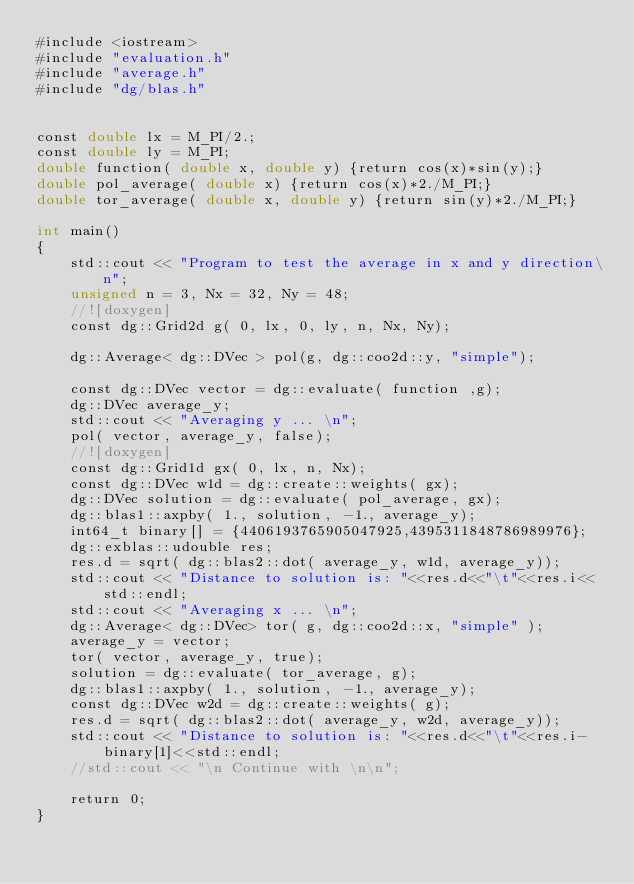<code> <loc_0><loc_0><loc_500><loc_500><_Cuda_>#include <iostream>
#include "evaluation.h"
#include "average.h"
#include "dg/blas.h"


const double lx = M_PI/2.;
const double ly = M_PI;
double function( double x, double y) {return cos(x)*sin(y);}
double pol_average( double x) {return cos(x)*2./M_PI;}
double tor_average( double x, double y) {return sin(y)*2./M_PI;}

int main()
{
    std::cout << "Program to test the average in x and y direction\n";
    unsigned n = 3, Nx = 32, Ny = 48;
    //![doxygen]
    const dg::Grid2d g( 0, lx, 0, ly, n, Nx, Ny);

    dg::Average< dg::DVec > pol(g, dg::coo2d::y, "simple");

    const dg::DVec vector = dg::evaluate( function ,g);
    dg::DVec average_y;
    std::cout << "Averaging y ... \n";
    pol( vector, average_y, false);
    //![doxygen]
    const dg::Grid1d gx( 0, lx, n, Nx);
    const dg::DVec w1d = dg::create::weights( gx);
    dg::DVec solution = dg::evaluate( pol_average, gx);
    dg::blas1::axpby( 1., solution, -1., average_y);
    int64_t binary[] = {4406193765905047925,4395311848786989976};
    dg::exblas::udouble res;
    res.d = sqrt( dg::blas2::dot( average_y, w1d, average_y));
    std::cout << "Distance to solution is: "<<res.d<<"\t"<<res.i<<std::endl;
    std::cout << "Averaging x ... \n";
    dg::Average< dg::DVec> tor( g, dg::coo2d::x, "simple" );
    average_y = vector;
    tor( vector, average_y, true);
    solution = dg::evaluate( tor_average, g);
    dg::blas1::axpby( 1., solution, -1., average_y);
    const dg::DVec w2d = dg::create::weights( g);
    res.d = sqrt( dg::blas2::dot( average_y, w2d, average_y));
    std::cout << "Distance to solution is: "<<res.d<<"\t"<<res.i-binary[1]<<std::endl;
    //std::cout << "\n Continue with \n\n";

    return 0;
}
</code> 